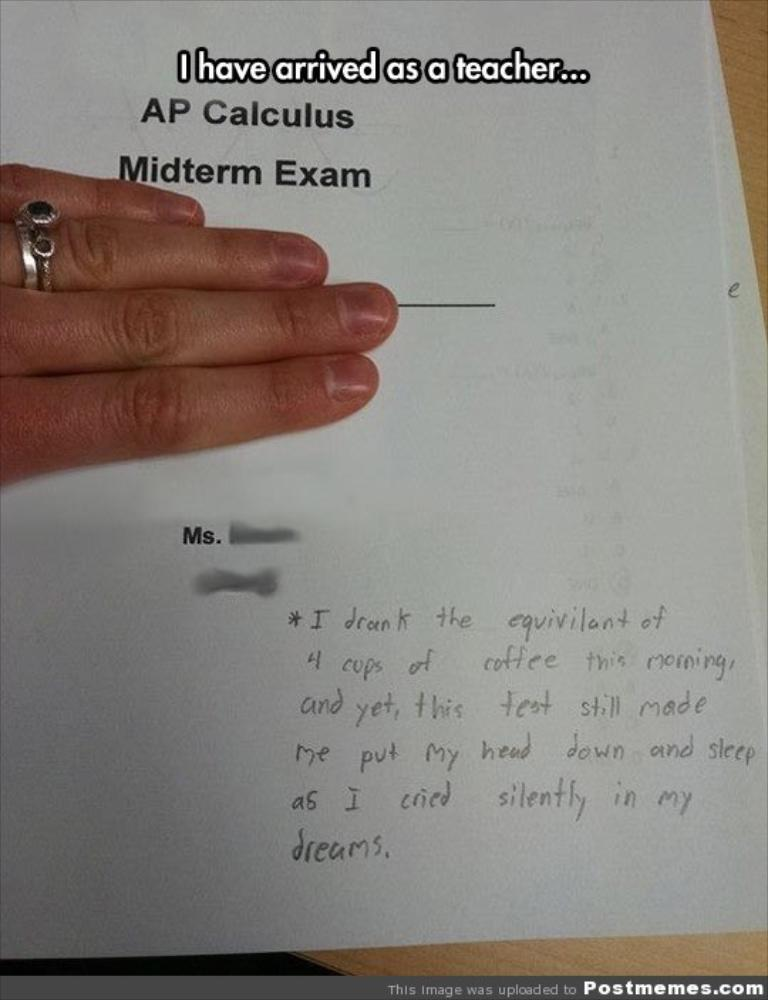What is the main subject of the image? There is a person in the image. What is the person doing with the papers? The person is placing a hand on the papers. Can you describe the content of the papers? There is writing on the paper. Where are the papers located? The paper is placed on a table. What type of range is visible in the image? There is no range present in the image. 